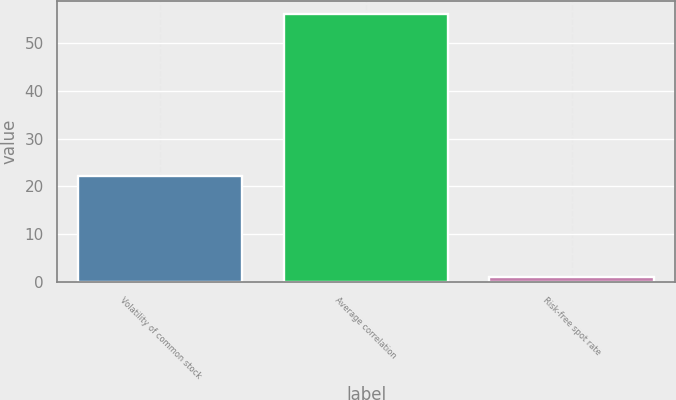Convert chart. <chart><loc_0><loc_0><loc_500><loc_500><bar_chart><fcel>Volatility of common stock<fcel>Average correlation<fcel>Risk-free spot rate<nl><fcel>22.2<fcel>56<fcel>1<nl></chart> 